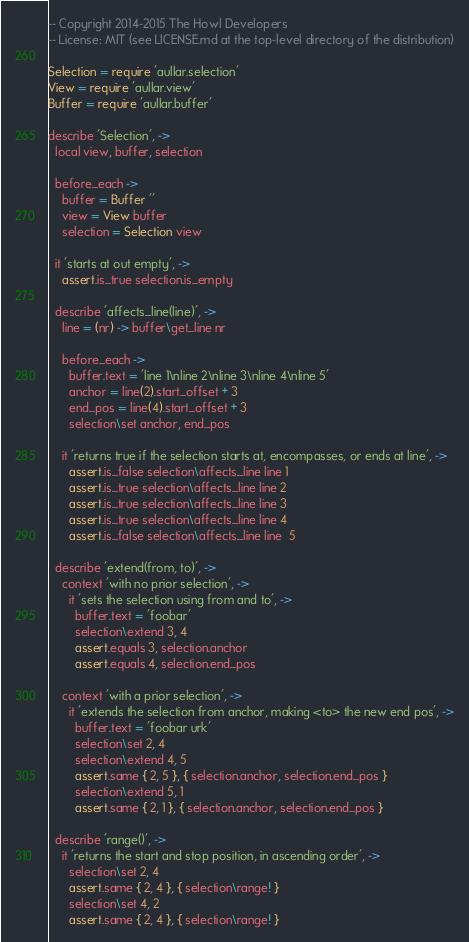<code> <loc_0><loc_0><loc_500><loc_500><_MoonScript_>-- Copyright 2014-2015 The Howl Developers
-- License: MIT (see LICENSE.md at the top-level directory of the distribution)

Selection = require 'aullar.selection'
View = require 'aullar.view'
Buffer = require 'aullar.buffer'

describe 'Selection', ->
  local view, buffer, selection

  before_each ->
    buffer = Buffer ''
    view = View buffer
    selection = Selection view

  it 'starts at out empty', ->
    assert.is_true selection.is_empty

  describe 'affects_line(line)', ->
    line = (nr) -> buffer\get_line nr

    before_each ->
      buffer.text = 'line 1\nline 2\nline 3\nline 4\nline 5'
      anchor = line(2).start_offset + 3
      end_pos = line(4).start_offset + 3
      selection\set anchor, end_pos

    it 'returns true if the selection starts at, encompasses, or ends at line', ->
      assert.is_false selection\affects_line line 1
      assert.is_true selection\affects_line line 2
      assert.is_true selection\affects_line line 3
      assert.is_true selection\affects_line line 4
      assert.is_false selection\affects_line line  5

  describe 'extend(from, to)', ->
    context 'with no prior selection', ->
      it 'sets the selection using from and to', ->
        buffer.text = 'foobar'
        selection\extend 3, 4
        assert.equals 3, selection.anchor
        assert.equals 4, selection.end_pos

    context 'with a prior selection', ->
      it 'extends the selection from anchor, making <to> the new end pos', ->
        buffer.text = 'foobar urk'
        selection\set 2, 4
        selection\extend 4, 5
        assert.same { 2, 5 }, { selection.anchor, selection.end_pos }
        selection\extend 5, 1
        assert.same { 2, 1 }, { selection.anchor, selection.end_pos }

  describe 'range()', ->
    it 'returns the start and stop position, in ascending order', ->
      selection\set 2, 4
      assert.same { 2, 4 }, { selection\range! }
      selection\set 4, 2
      assert.same { 2, 4 }, { selection\range! }
</code> 